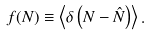Convert formula to latex. <formula><loc_0><loc_0><loc_500><loc_500>f ( N ) \equiv \left < \delta \left ( N - \hat { N } \right ) \right > .</formula> 